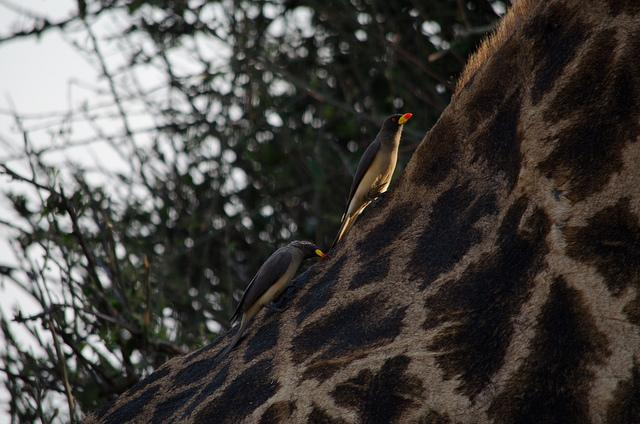Where are the birds standing on? giraffe 